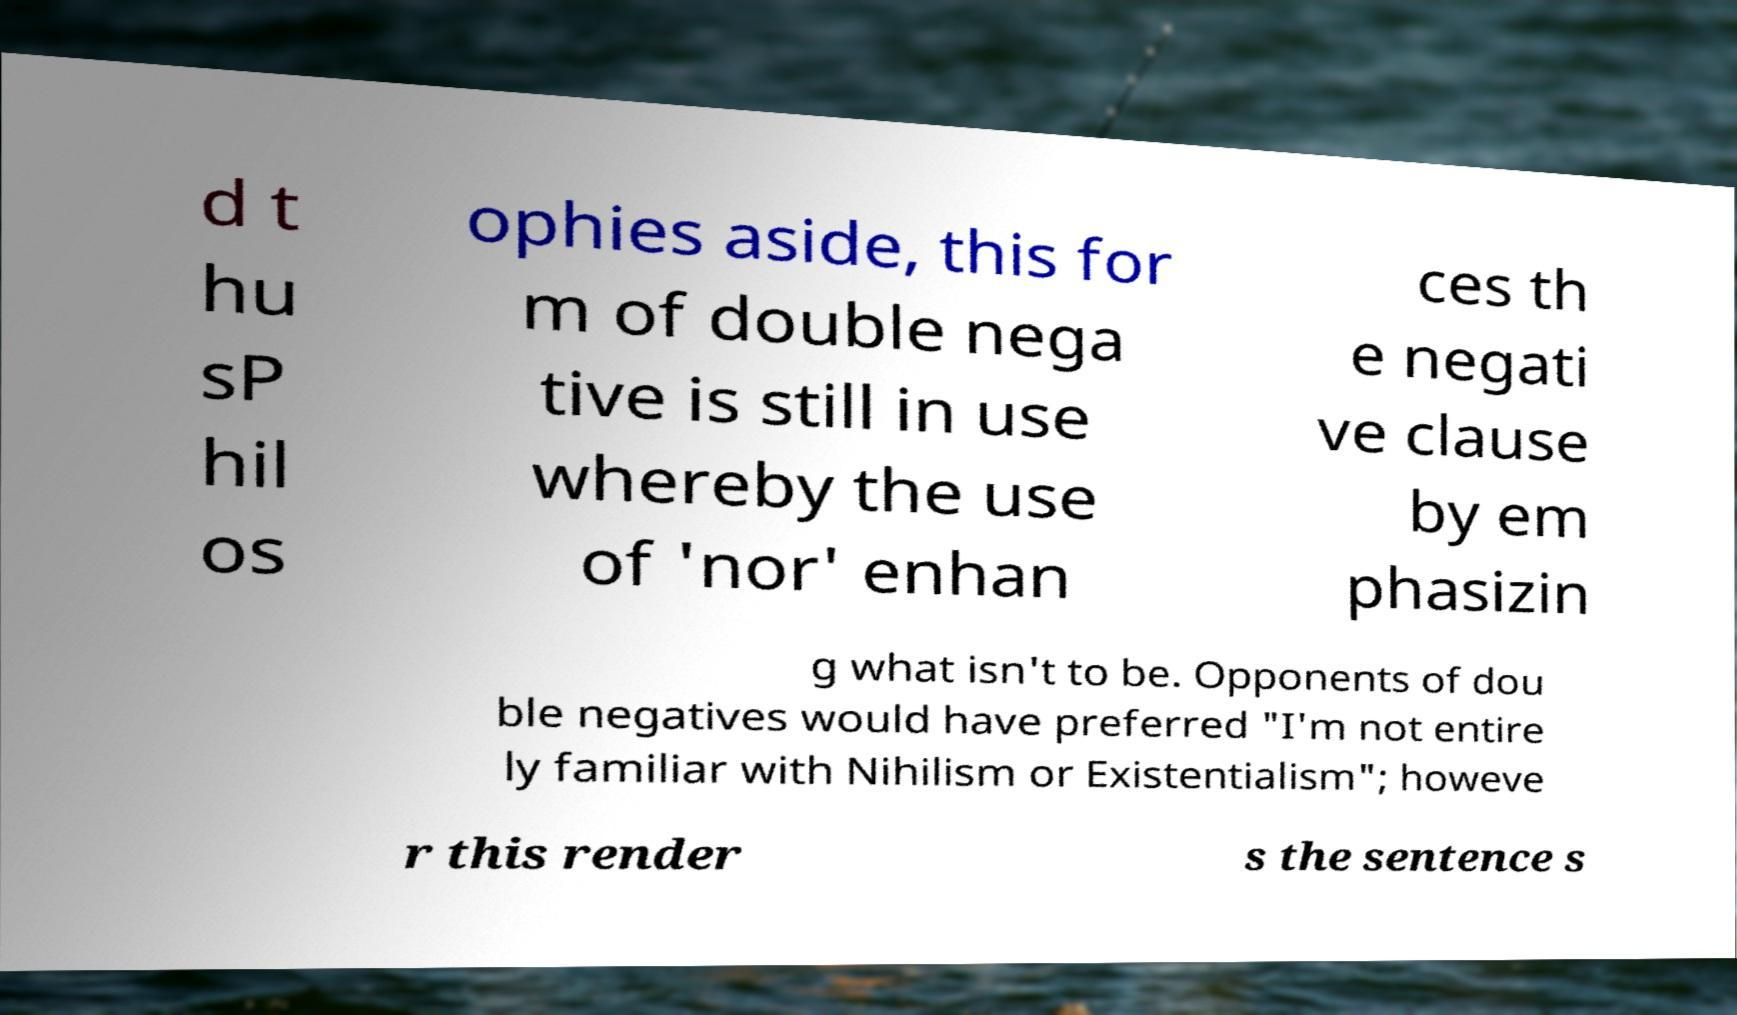Could you assist in decoding the text presented in this image and type it out clearly? d t hu sP hil os ophies aside, this for m of double nega tive is still in use whereby the use of 'nor' enhan ces th e negati ve clause by em phasizin g what isn't to be. Opponents of dou ble negatives would have preferred "I'm not entire ly familiar with Nihilism or Existentialism"; howeve r this render s the sentence s 